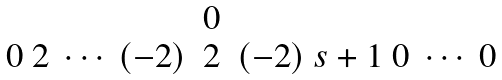<formula> <loc_0><loc_0><loc_500><loc_500>\begin{matrix} & 0 & \\ 0 \ 2 \ \cdots \ ( - 2 ) & 2 & ( - 2 ) \ s + 1 \ 0 \ \cdots \ 0 \end{matrix}</formula> 